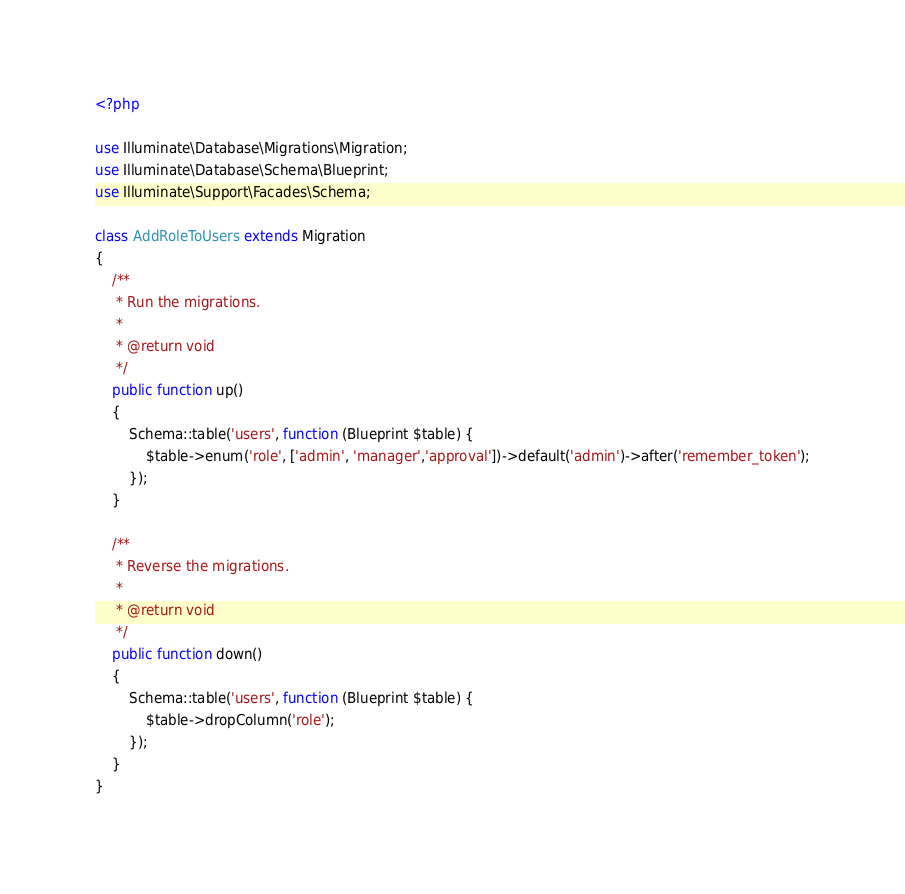Convert code to text. <code><loc_0><loc_0><loc_500><loc_500><_PHP_><?php

use Illuminate\Database\Migrations\Migration;
use Illuminate\Database\Schema\Blueprint;
use Illuminate\Support\Facades\Schema;

class AddRoleToUsers extends Migration
{
    /**
     * Run the migrations.
     *
     * @return void
     */
    public function up()
    {
        Schema::table('users', function (Blueprint $table) {
            $table->enum('role', ['admin', 'manager','approval'])->default('admin')->after('remember_token');
        });
    }

    /**
     * Reverse the migrations.
     *
     * @return void
     */
    public function down()
    {
        Schema::table('users', function (Blueprint $table) {
            $table->dropColumn('role');
        });
    }
}
</code> 